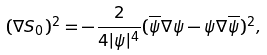Convert formula to latex. <formula><loc_0><loc_0><loc_500><loc_500>( \nabla S _ { 0 } ) ^ { 2 } = - \frac { 2 } { 4 | \psi | ^ { 4 } } ( \overline { \psi } \nabla \psi - \psi \nabla \overline { \psi } ) ^ { 2 } ,</formula> 